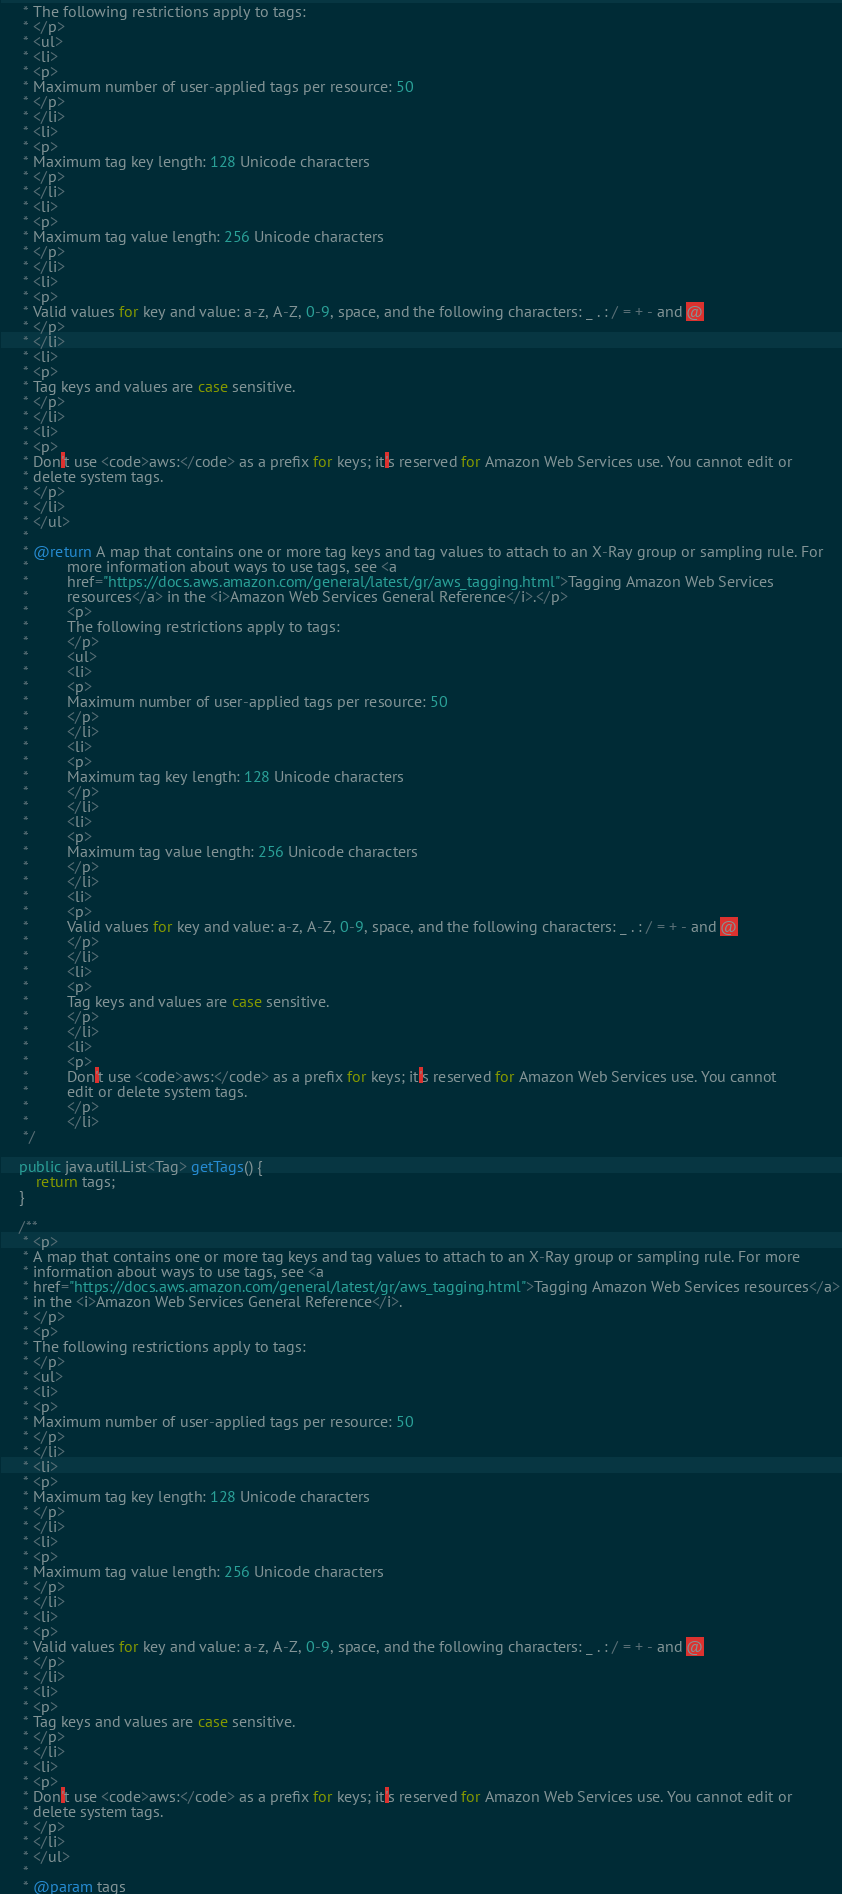Convert code to text. <code><loc_0><loc_0><loc_500><loc_500><_Java_>     * The following restrictions apply to tags:
     * </p>
     * <ul>
     * <li>
     * <p>
     * Maximum number of user-applied tags per resource: 50
     * </p>
     * </li>
     * <li>
     * <p>
     * Maximum tag key length: 128 Unicode characters
     * </p>
     * </li>
     * <li>
     * <p>
     * Maximum tag value length: 256 Unicode characters
     * </p>
     * </li>
     * <li>
     * <p>
     * Valid values for key and value: a-z, A-Z, 0-9, space, and the following characters: _ . : / = + - and @
     * </p>
     * </li>
     * <li>
     * <p>
     * Tag keys and values are case sensitive.
     * </p>
     * </li>
     * <li>
     * <p>
     * Don't use <code>aws:</code> as a prefix for keys; it's reserved for Amazon Web Services use. You cannot edit or
     * delete system tags.
     * </p>
     * </li>
     * </ul>
     * 
     * @return A map that contains one or more tag keys and tag values to attach to an X-Ray group or sampling rule. For
     *         more information about ways to use tags, see <a
     *         href="https://docs.aws.amazon.com/general/latest/gr/aws_tagging.html">Tagging Amazon Web Services
     *         resources</a> in the <i>Amazon Web Services General Reference</i>.</p>
     *         <p>
     *         The following restrictions apply to tags:
     *         </p>
     *         <ul>
     *         <li>
     *         <p>
     *         Maximum number of user-applied tags per resource: 50
     *         </p>
     *         </li>
     *         <li>
     *         <p>
     *         Maximum tag key length: 128 Unicode characters
     *         </p>
     *         </li>
     *         <li>
     *         <p>
     *         Maximum tag value length: 256 Unicode characters
     *         </p>
     *         </li>
     *         <li>
     *         <p>
     *         Valid values for key and value: a-z, A-Z, 0-9, space, and the following characters: _ . : / = + - and @
     *         </p>
     *         </li>
     *         <li>
     *         <p>
     *         Tag keys and values are case sensitive.
     *         </p>
     *         </li>
     *         <li>
     *         <p>
     *         Don't use <code>aws:</code> as a prefix for keys; it's reserved for Amazon Web Services use. You cannot
     *         edit or delete system tags.
     *         </p>
     *         </li>
     */

    public java.util.List<Tag> getTags() {
        return tags;
    }

    /**
     * <p>
     * A map that contains one or more tag keys and tag values to attach to an X-Ray group or sampling rule. For more
     * information about ways to use tags, see <a
     * href="https://docs.aws.amazon.com/general/latest/gr/aws_tagging.html">Tagging Amazon Web Services resources</a>
     * in the <i>Amazon Web Services General Reference</i>.
     * </p>
     * <p>
     * The following restrictions apply to tags:
     * </p>
     * <ul>
     * <li>
     * <p>
     * Maximum number of user-applied tags per resource: 50
     * </p>
     * </li>
     * <li>
     * <p>
     * Maximum tag key length: 128 Unicode characters
     * </p>
     * </li>
     * <li>
     * <p>
     * Maximum tag value length: 256 Unicode characters
     * </p>
     * </li>
     * <li>
     * <p>
     * Valid values for key and value: a-z, A-Z, 0-9, space, and the following characters: _ . : / = + - and @
     * </p>
     * </li>
     * <li>
     * <p>
     * Tag keys and values are case sensitive.
     * </p>
     * </li>
     * <li>
     * <p>
     * Don't use <code>aws:</code> as a prefix for keys; it's reserved for Amazon Web Services use. You cannot edit or
     * delete system tags.
     * </p>
     * </li>
     * </ul>
     * 
     * @param tags</code> 